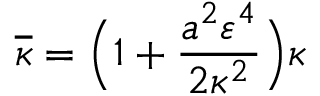Convert formula to latex. <formula><loc_0><loc_0><loc_500><loc_500>\overline { \kappa } = \left ( 1 + \frac { a ^ { 2 } \varepsilon ^ { 4 } } { 2 \kappa ^ { 2 } } \right ) \kappa</formula> 